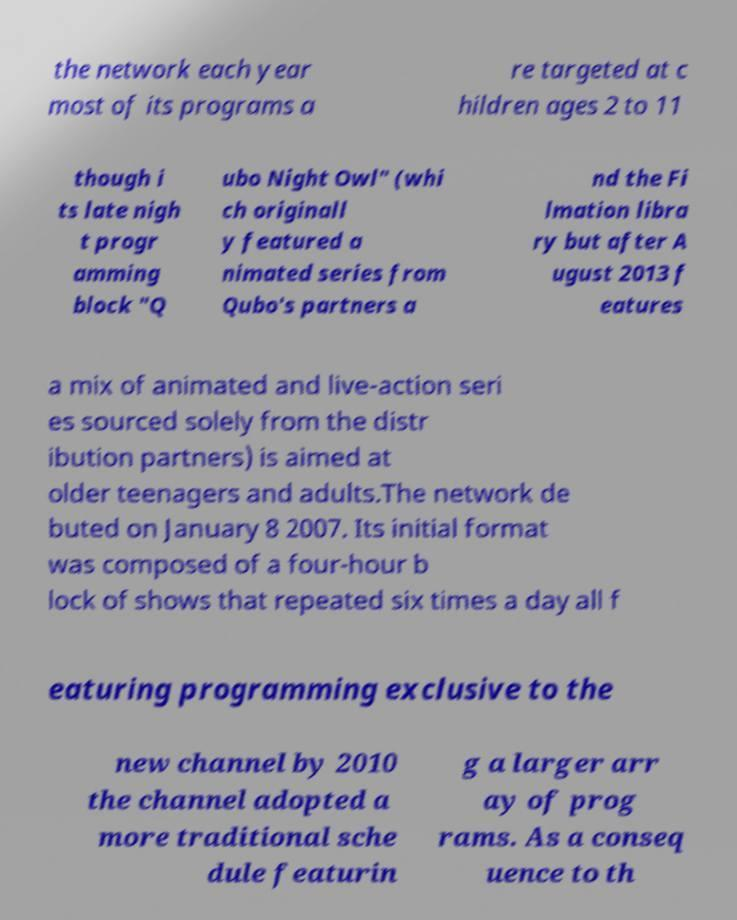Please read and relay the text visible in this image. What does it say? the network each year most of its programs a re targeted at c hildren ages 2 to 11 though i ts late nigh t progr amming block "Q ubo Night Owl" (whi ch originall y featured a nimated series from Qubo's partners a nd the Fi lmation libra ry but after A ugust 2013 f eatures a mix of animated and live-action seri es sourced solely from the distr ibution partners) is aimed at older teenagers and adults.The network de buted on January 8 2007. Its initial format was composed of a four-hour b lock of shows that repeated six times a day all f eaturing programming exclusive to the new channel by 2010 the channel adopted a more traditional sche dule featurin g a larger arr ay of prog rams. As a conseq uence to th 